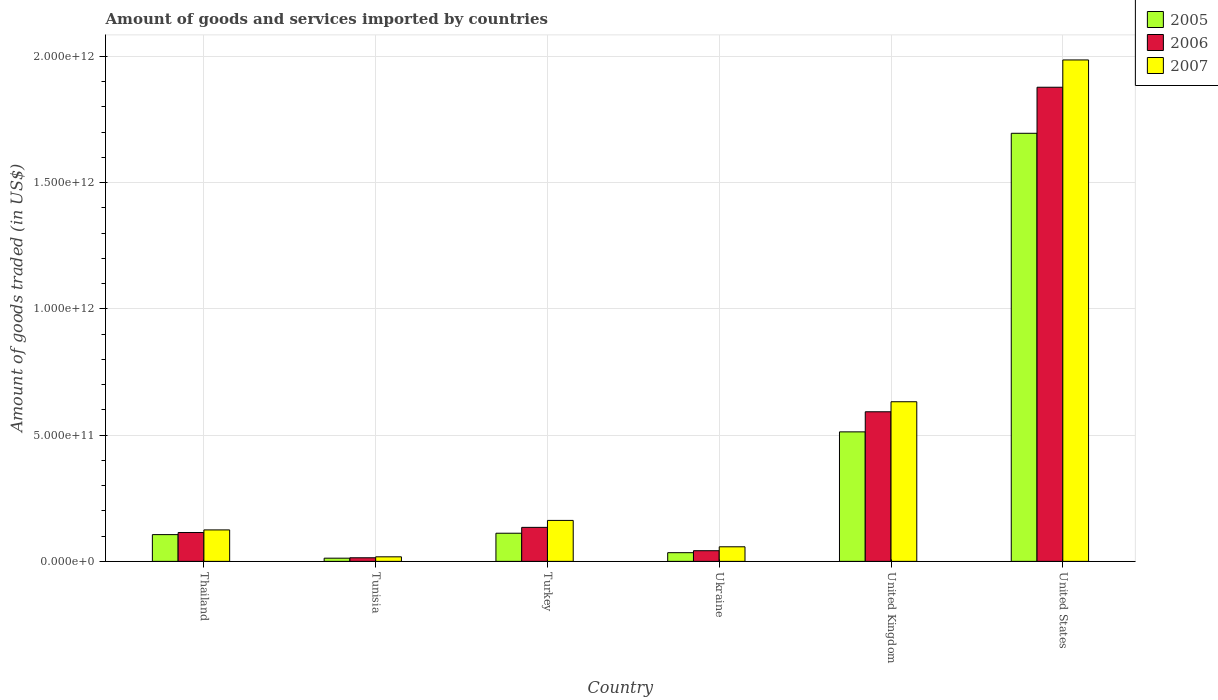How many different coloured bars are there?
Your response must be concise. 3. Are the number of bars per tick equal to the number of legend labels?
Your answer should be compact. Yes. Are the number of bars on each tick of the X-axis equal?
Ensure brevity in your answer.  Yes. What is the label of the 3rd group of bars from the left?
Your answer should be very brief. Turkey. In how many cases, is the number of bars for a given country not equal to the number of legend labels?
Offer a terse response. 0. What is the total amount of goods and services imported in 2007 in Thailand?
Ensure brevity in your answer.  1.25e+11. Across all countries, what is the maximum total amount of goods and services imported in 2007?
Keep it short and to the point. 1.99e+12. Across all countries, what is the minimum total amount of goods and services imported in 2006?
Your answer should be compact. 1.42e+1. In which country was the total amount of goods and services imported in 2007 maximum?
Make the answer very short. United States. In which country was the total amount of goods and services imported in 2005 minimum?
Provide a short and direct response. Tunisia. What is the total total amount of goods and services imported in 2005 in the graph?
Make the answer very short. 2.47e+12. What is the difference between the total amount of goods and services imported in 2005 in Thailand and that in Tunisia?
Your response must be concise. 9.34e+1. What is the difference between the total amount of goods and services imported in 2007 in Thailand and the total amount of goods and services imported in 2005 in Turkey?
Your response must be concise. 1.32e+1. What is the average total amount of goods and services imported in 2006 per country?
Ensure brevity in your answer.  4.63e+11. What is the difference between the total amount of goods and services imported of/in 2006 and total amount of goods and services imported of/in 2007 in United Kingdom?
Keep it short and to the point. -3.98e+1. What is the ratio of the total amount of goods and services imported in 2007 in Turkey to that in United Kingdom?
Give a very brief answer. 0.26. What is the difference between the highest and the second highest total amount of goods and services imported in 2005?
Offer a very short reply. 1.18e+12. What is the difference between the highest and the lowest total amount of goods and services imported in 2007?
Offer a terse response. 1.97e+12. Is the sum of the total amount of goods and services imported in 2007 in United Kingdom and United States greater than the maximum total amount of goods and services imported in 2006 across all countries?
Ensure brevity in your answer.  Yes. What does the 3rd bar from the left in United States represents?
Offer a very short reply. 2007. Is it the case that in every country, the sum of the total amount of goods and services imported in 2007 and total amount of goods and services imported in 2005 is greater than the total amount of goods and services imported in 2006?
Keep it short and to the point. Yes. Are all the bars in the graph horizontal?
Your answer should be very brief. No. What is the difference between two consecutive major ticks on the Y-axis?
Provide a short and direct response. 5.00e+11. Are the values on the major ticks of Y-axis written in scientific E-notation?
Your answer should be compact. Yes. Does the graph contain any zero values?
Keep it short and to the point. No. Does the graph contain grids?
Provide a succinct answer. Yes. Where does the legend appear in the graph?
Your response must be concise. Top right. How many legend labels are there?
Give a very brief answer. 3. What is the title of the graph?
Offer a terse response. Amount of goods and services imported by countries. What is the label or title of the X-axis?
Ensure brevity in your answer.  Country. What is the label or title of the Y-axis?
Give a very brief answer. Amount of goods traded (in US$). What is the Amount of goods traded (in US$) of 2005 in Thailand?
Provide a short and direct response. 1.06e+11. What is the Amount of goods traded (in US$) in 2006 in Thailand?
Make the answer very short. 1.14e+11. What is the Amount of goods traded (in US$) in 2007 in Thailand?
Provide a succinct answer. 1.25e+11. What is the Amount of goods traded (in US$) of 2005 in Tunisia?
Provide a succinct answer. 1.26e+1. What is the Amount of goods traded (in US$) in 2006 in Tunisia?
Make the answer very short. 1.42e+1. What is the Amount of goods traded (in US$) of 2007 in Tunisia?
Offer a very short reply. 1.80e+1. What is the Amount of goods traded (in US$) in 2005 in Turkey?
Offer a very short reply. 1.11e+11. What is the Amount of goods traded (in US$) of 2006 in Turkey?
Keep it short and to the point. 1.35e+11. What is the Amount of goods traded (in US$) in 2007 in Turkey?
Provide a succinct answer. 1.62e+11. What is the Amount of goods traded (in US$) of 2005 in Ukraine?
Ensure brevity in your answer.  3.44e+1. What is the Amount of goods traded (in US$) of 2006 in Ukraine?
Provide a succinct answer. 4.22e+1. What is the Amount of goods traded (in US$) of 2007 in Ukraine?
Provide a short and direct response. 5.78e+1. What is the Amount of goods traded (in US$) in 2005 in United Kingdom?
Provide a succinct answer. 5.13e+11. What is the Amount of goods traded (in US$) in 2006 in United Kingdom?
Make the answer very short. 5.93e+11. What is the Amount of goods traded (in US$) of 2007 in United Kingdom?
Ensure brevity in your answer.  6.32e+11. What is the Amount of goods traded (in US$) of 2005 in United States?
Keep it short and to the point. 1.70e+12. What is the Amount of goods traded (in US$) of 2006 in United States?
Offer a terse response. 1.88e+12. What is the Amount of goods traded (in US$) of 2007 in United States?
Your response must be concise. 1.99e+12. Across all countries, what is the maximum Amount of goods traded (in US$) in 2005?
Keep it short and to the point. 1.70e+12. Across all countries, what is the maximum Amount of goods traded (in US$) of 2006?
Offer a terse response. 1.88e+12. Across all countries, what is the maximum Amount of goods traded (in US$) of 2007?
Give a very brief answer. 1.99e+12. Across all countries, what is the minimum Amount of goods traded (in US$) in 2005?
Ensure brevity in your answer.  1.26e+1. Across all countries, what is the minimum Amount of goods traded (in US$) in 2006?
Offer a very short reply. 1.42e+1. Across all countries, what is the minimum Amount of goods traded (in US$) in 2007?
Your answer should be compact. 1.80e+1. What is the total Amount of goods traded (in US$) of 2005 in the graph?
Offer a very short reply. 2.47e+12. What is the total Amount of goods traded (in US$) in 2006 in the graph?
Keep it short and to the point. 2.78e+12. What is the total Amount of goods traded (in US$) in 2007 in the graph?
Your answer should be compact. 2.98e+12. What is the difference between the Amount of goods traded (in US$) in 2005 in Thailand and that in Tunisia?
Make the answer very short. 9.34e+1. What is the difference between the Amount of goods traded (in US$) in 2006 in Thailand and that in Tunisia?
Offer a very short reply. 1.00e+11. What is the difference between the Amount of goods traded (in US$) of 2007 in Thailand and that in Tunisia?
Offer a terse response. 1.07e+11. What is the difference between the Amount of goods traded (in US$) of 2005 in Thailand and that in Turkey?
Your response must be concise. -5.47e+09. What is the difference between the Amount of goods traded (in US$) of 2006 in Thailand and that in Turkey?
Provide a succinct answer. -2.04e+1. What is the difference between the Amount of goods traded (in US$) in 2007 in Thailand and that in Turkey?
Give a very brief answer. -3.76e+1. What is the difference between the Amount of goods traded (in US$) of 2005 in Thailand and that in Ukraine?
Make the answer very short. 7.16e+1. What is the difference between the Amount of goods traded (in US$) of 2006 in Thailand and that in Ukraine?
Ensure brevity in your answer.  7.20e+1. What is the difference between the Amount of goods traded (in US$) in 2007 in Thailand and that in Ukraine?
Keep it short and to the point. 6.69e+1. What is the difference between the Amount of goods traded (in US$) of 2005 in Thailand and that in United Kingdom?
Ensure brevity in your answer.  -4.07e+11. What is the difference between the Amount of goods traded (in US$) of 2006 in Thailand and that in United Kingdom?
Your answer should be very brief. -4.78e+11. What is the difference between the Amount of goods traded (in US$) of 2007 in Thailand and that in United Kingdom?
Ensure brevity in your answer.  -5.08e+11. What is the difference between the Amount of goods traded (in US$) of 2005 in Thailand and that in United States?
Provide a short and direct response. -1.59e+12. What is the difference between the Amount of goods traded (in US$) in 2006 in Thailand and that in United States?
Offer a terse response. -1.76e+12. What is the difference between the Amount of goods traded (in US$) in 2007 in Thailand and that in United States?
Ensure brevity in your answer.  -1.86e+12. What is the difference between the Amount of goods traded (in US$) of 2005 in Tunisia and that in Turkey?
Provide a succinct answer. -9.89e+1. What is the difference between the Amount of goods traded (in US$) in 2006 in Tunisia and that in Turkey?
Your answer should be compact. -1.20e+11. What is the difference between the Amount of goods traded (in US$) of 2007 in Tunisia and that in Turkey?
Provide a succinct answer. -1.44e+11. What is the difference between the Amount of goods traded (in US$) in 2005 in Tunisia and that in Ukraine?
Provide a succinct answer. -2.18e+1. What is the difference between the Amount of goods traded (in US$) of 2006 in Tunisia and that in Ukraine?
Provide a short and direct response. -2.80e+1. What is the difference between the Amount of goods traded (in US$) of 2007 in Tunisia and that in Ukraine?
Offer a very short reply. -3.97e+1. What is the difference between the Amount of goods traded (in US$) of 2005 in Tunisia and that in United Kingdom?
Your answer should be very brief. -5.00e+11. What is the difference between the Amount of goods traded (in US$) in 2006 in Tunisia and that in United Kingdom?
Provide a short and direct response. -5.78e+11. What is the difference between the Amount of goods traded (in US$) in 2007 in Tunisia and that in United Kingdom?
Offer a terse response. -6.14e+11. What is the difference between the Amount of goods traded (in US$) of 2005 in Tunisia and that in United States?
Your answer should be very brief. -1.68e+12. What is the difference between the Amount of goods traded (in US$) in 2006 in Tunisia and that in United States?
Give a very brief answer. -1.86e+12. What is the difference between the Amount of goods traded (in US$) of 2007 in Tunisia and that in United States?
Give a very brief answer. -1.97e+12. What is the difference between the Amount of goods traded (in US$) of 2005 in Turkey and that in Ukraine?
Provide a succinct answer. 7.71e+1. What is the difference between the Amount of goods traded (in US$) in 2006 in Turkey and that in Ukraine?
Provide a succinct answer. 9.25e+1. What is the difference between the Amount of goods traded (in US$) in 2007 in Turkey and that in Ukraine?
Keep it short and to the point. 1.04e+11. What is the difference between the Amount of goods traded (in US$) in 2005 in Turkey and that in United Kingdom?
Your answer should be compact. -4.02e+11. What is the difference between the Amount of goods traded (in US$) of 2006 in Turkey and that in United Kingdom?
Make the answer very short. -4.58e+11. What is the difference between the Amount of goods traded (in US$) in 2007 in Turkey and that in United Kingdom?
Your answer should be compact. -4.70e+11. What is the difference between the Amount of goods traded (in US$) in 2005 in Turkey and that in United States?
Your response must be concise. -1.58e+12. What is the difference between the Amount of goods traded (in US$) in 2006 in Turkey and that in United States?
Provide a short and direct response. -1.74e+12. What is the difference between the Amount of goods traded (in US$) of 2007 in Turkey and that in United States?
Make the answer very short. -1.82e+12. What is the difference between the Amount of goods traded (in US$) in 2005 in Ukraine and that in United Kingdom?
Keep it short and to the point. -4.79e+11. What is the difference between the Amount of goods traded (in US$) of 2006 in Ukraine and that in United Kingdom?
Provide a short and direct response. -5.50e+11. What is the difference between the Amount of goods traded (in US$) in 2007 in Ukraine and that in United Kingdom?
Make the answer very short. -5.75e+11. What is the difference between the Amount of goods traded (in US$) in 2005 in Ukraine and that in United States?
Your answer should be very brief. -1.66e+12. What is the difference between the Amount of goods traded (in US$) of 2006 in Ukraine and that in United States?
Offer a very short reply. -1.84e+12. What is the difference between the Amount of goods traded (in US$) of 2007 in Ukraine and that in United States?
Give a very brief answer. -1.93e+12. What is the difference between the Amount of goods traded (in US$) of 2005 in United Kingdom and that in United States?
Make the answer very short. -1.18e+12. What is the difference between the Amount of goods traded (in US$) in 2006 in United Kingdom and that in United States?
Give a very brief answer. -1.29e+12. What is the difference between the Amount of goods traded (in US$) in 2007 in United Kingdom and that in United States?
Ensure brevity in your answer.  -1.35e+12. What is the difference between the Amount of goods traded (in US$) in 2005 in Thailand and the Amount of goods traded (in US$) in 2006 in Tunisia?
Provide a short and direct response. 9.18e+1. What is the difference between the Amount of goods traded (in US$) in 2005 in Thailand and the Amount of goods traded (in US$) in 2007 in Tunisia?
Give a very brief answer. 8.80e+1. What is the difference between the Amount of goods traded (in US$) of 2006 in Thailand and the Amount of goods traded (in US$) of 2007 in Tunisia?
Your response must be concise. 9.62e+1. What is the difference between the Amount of goods traded (in US$) in 2005 in Thailand and the Amount of goods traded (in US$) in 2006 in Turkey?
Offer a very short reply. -2.87e+1. What is the difference between the Amount of goods traded (in US$) in 2005 in Thailand and the Amount of goods traded (in US$) in 2007 in Turkey?
Give a very brief answer. -5.62e+1. What is the difference between the Amount of goods traded (in US$) of 2006 in Thailand and the Amount of goods traded (in US$) of 2007 in Turkey?
Give a very brief answer. -4.79e+1. What is the difference between the Amount of goods traded (in US$) of 2005 in Thailand and the Amount of goods traded (in US$) of 2006 in Ukraine?
Your answer should be compact. 6.38e+1. What is the difference between the Amount of goods traded (in US$) in 2005 in Thailand and the Amount of goods traded (in US$) in 2007 in Ukraine?
Offer a terse response. 4.82e+1. What is the difference between the Amount of goods traded (in US$) of 2006 in Thailand and the Amount of goods traded (in US$) of 2007 in Ukraine?
Your answer should be compact. 5.65e+1. What is the difference between the Amount of goods traded (in US$) in 2005 in Thailand and the Amount of goods traded (in US$) in 2006 in United Kingdom?
Offer a very short reply. -4.87e+11. What is the difference between the Amount of goods traded (in US$) in 2005 in Thailand and the Amount of goods traded (in US$) in 2007 in United Kingdom?
Your response must be concise. -5.26e+11. What is the difference between the Amount of goods traded (in US$) in 2006 in Thailand and the Amount of goods traded (in US$) in 2007 in United Kingdom?
Your answer should be very brief. -5.18e+11. What is the difference between the Amount of goods traded (in US$) in 2005 in Thailand and the Amount of goods traded (in US$) in 2006 in United States?
Offer a very short reply. -1.77e+12. What is the difference between the Amount of goods traded (in US$) in 2005 in Thailand and the Amount of goods traded (in US$) in 2007 in United States?
Offer a very short reply. -1.88e+12. What is the difference between the Amount of goods traded (in US$) of 2006 in Thailand and the Amount of goods traded (in US$) of 2007 in United States?
Offer a very short reply. -1.87e+12. What is the difference between the Amount of goods traded (in US$) in 2005 in Tunisia and the Amount of goods traded (in US$) in 2006 in Turkey?
Give a very brief answer. -1.22e+11. What is the difference between the Amount of goods traded (in US$) in 2005 in Tunisia and the Amount of goods traded (in US$) in 2007 in Turkey?
Your answer should be compact. -1.50e+11. What is the difference between the Amount of goods traded (in US$) in 2006 in Tunisia and the Amount of goods traded (in US$) in 2007 in Turkey?
Make the answer very short. -1.48e+11. What is the difference between the Amount of goods traded (in US$) of 2005 in Tunisia and the Amount of goods traded (in US$) of 2006 in Ukraine?
Provide a succinct answer. -2.96e+1. What is the difference between the Amount of goods traded (in US$) of 2005 in Tunisia and the Amount of goods traded (in US$) of 2007 in Ukraine?
Offer a very short reply. -4.52e+1. What is the difference between the Amount of goods traded (in US$) of 2006 in Tunisia and the Amount of goods traded (in US$) of 2007 in Ukraine?
Ensure brevity in your answer.  -4.36e+1. What is the difference between the Amount of goods traded (in US$) of 2005 in Tunisia and the Amount of goods traded (in US$) of 2006 in United Kingdom?
Keep it short and to the point. -5.80e+11. What is the difference between the Amount of goods traded (in US$) in 2005 in Tunisia and the Amount of goods traded (in US$) in 2007 in United Kingdom?
Your answer should be very brief. -6.20e+11. What is the difference between the Amount of goods traded (in US$) of 2006 in Tunisia and the Amount of goods traded (in US$) of 2007 in United Kingdom?
Offer a terse response. -6.18e+11. What is the difference between the Amount of goods traded (in US$) of 2005 in Tunisia and the Amount of goods traded (in US$) of 2006 in United States?
Your answer should be compact. -1.87e+12. What is the difference between the Amount of goods traded (in US$) of 2005 in Tunisia and the Amount of goods traded (in US$) of 2007 in United States?
Make the answer very short. -1.97e+12. What is the difference between the Amount of goods traded (in US$) of 2006 in Tunisia and the Amount of goods traded (in US$) of 2007 in United States?
Make the answer very short. -1.97e+12. What is the difference between the Amount of goods traded (in US$) in 2005 in Turkey and the Amount of goods traded (in US$) in 2006 in Ukraine?
Offer a very short reply. 6.92e+1. What is the difference between the Amount of goods traded (in US$) of 2005 in Turkey and the Amount of goods traded (in US$) of 2007 in Ukraine?
Keep it short and to the point. 5.37e+1. What is the difference between the Amount of goods traded (in US$) of 2006 in Turkey and the Amount of goods traded (in US$) of 2007 in Ukraine?
Ensure brevity in your answer.  7.69e+1. What is the difference between the Amount of goods traded (in US$) of 2005 in Turkey and the Amount of goods traded (in US$) of 2006 in United Kingdom?
Your answer should be very brief. -4.81e+11. What is the difference between the Amount of goods traded (in US$) in 2005 in Turkey and the Amount of goods traded (in US$) in 2007 in United Kingdom?
Make the answer very short. -5.21e+11. What is the difference between the Amount of goods traded (in US$) in 2006 in Turkey and the Amount of goods traded (in US$) in 2007 in United Kingdom?
Offer a terse response. -4.98e+11. What is the difference between the Amount of goods traded (in US$) in 2005 in Turkey and the Amount of goods traded (in US$) in 2006 in United States?
Offer a terse response. -1.77e+12. What is the difference between the Amount of goods traded (in US$) in 2005 in Turkey and the Amount of goods traded (in US$) in 2007 in United States?
Your response must be concise. -1.87e+12. What is the difference between the Amount of goods traded (in US$) of 2006 in Turkey and the Amount of goods traded (in US$) of 2007 in United States?
Give a very brief answer. -1.85e+12. What is the difference between the Amount of goods traded (in US$) in 2005 in Ukraine and the Amount of goods traded (in US$) in 2006 in United Kingdom?
Give a very brief answer. -5.58e+11. What is the difference between the Amount of goods traded (in US$) of 2005 in Ukraine and the Amount of goods traded (in US$) of 2007 in United Kingdom?
Make the answer very short. -5.98e+11. What is the difference between the Amount of goods traded (in US$) in 2006 in Ukraine and the Amount of goods traded (in US$) in 2007 in United Kingdom?
Keep it short and to the point. -5.90e+11. What is the difference between the Amount of goods traded (in US$) in 2005 in Ukraine and the Amount of goods traded (in US$) in 2006 in United States?
Offer a very short reply. -1.84e+12. What is the difference between the Amount of goods traded (in US$) of 2005 in Ukraine and the Amount of goods traded (in US$) of 2007 in United States?
Ensure brevity in your answer.  -1.95e+12. What is the difference between the Amount of goods traded (in US$) of 2006 in Ukraine and the Amount of goods traded (in US$) of 2007 in United States?
Your answer should be compact. -1.94e+12. What is the difference between the Amount of goods traded (in US$) of 2005 in United Kingdom and the Amount of goods traded (in US$) of 2006 in United States?
Give a very brief answer. -1.37e+12. What is the difference between the Amount of goods traded (in US$) in 2005 in United Kingdom and the Amount of goods traded (in US$) in 2007 in United States?
Keep it short and to the point. -1.47e+12. What is the difference between the Amount of goods traded (in US$) of 2006 in United Kingdom and the Amount of goods traded (in US$) of 2007 in United States?
Make the answer very short. -1.39e+12. What is the average Amount of goods traded (in US$) in 2005 per country?
Provide a succinct answer. 4.12e+11. What is the average Amount of goods traded (in US$) in 2006 per country?
Offer a very short reply. 4.63e+11. What is the average Amount of goods traded (in US$) of 2007 per country?
Keep it short and to the point. 4.97e+11. What is the difference between the Amount of goods traded (in US$) in 2005 and Amount of goods traded (in US$) in 2006 in Thailand?
Offer a terse response. -8.29e+09. What is the difference between the Amount of goods traded (in US$) of 2005 and Amount of goods traded (in US$) of 2007 in Thailand?
Your answer should be compact. -1.86e+1. What is the difference between the Amount of goods traded (in US$) of 2006 and Amount of goods traded (in US$) of 2007 in Thailand?
Your answer should be very brief. -1.03e+1. What is the difference between the Amount of goods traded (in US$) in 2005 and Amount of goods traded (in US$) in 2006 in Tunisia?
Give a very brief answer. -1.61e+09. What is the difference between the Amount of goods traded (in US$) of 2005 and Amount of goods traded (in US$) of 2007 in Tunisia?
Your answer should be very brief. -5.43e+09. What is the difference between the Amount of goods traded (in US$) in 2006 and Amount of goods traded (in US$) in 2007 in Tunisia?
Give a very brief answer. -3.82e+09. What is the difference between the Amount of goods traded (in US$) of 2005 and Amount of goods traded (in US$) of 2006 in Turkey?
Your answer should be very brief. -2.32e+1. What is the difference between the Amount of goods traded (in US$) in 2005 and Amount of goods traded (in US$) in 2007 in Turkey?
Provide a short and direct response. -5.08e+1. What is the difference between the Amount of goods traded (in US$) in 2006 and Amount of goods traded (in US$) in 2007 in Turkey?
Ensure brevity in your answer.  -2.75e+1. What is the difference between the Amount of goods traded (in US$) in 2005 and Amount of goods traded (in US$) in 2006 in Ukraine?
Offer a terse response. -7.84e+09. What is the difference between the Amount of goods traded (in US$) in 2005 and Amount of goods traded (in US$) in 2007 in Ukraine?
Your answer should be compact. -2.34e+1. What is the difference between the Amount of goods traded (in US$) in 2006 and Amount of goods traded (in US$) in 2007 in Ukraine?
Provide a succinct answer. -1.55e+1. What is the difference between the Amount of goods traded (in US$) in 2005 and Amount of goods traded (in US$) in 2006 in United Kingdom?
Keep it short and to the point. -7.96e+1. What is the difference between the Amount of goods traded (in US$) in 2005 and Amount of goods traded (in US$) in 2007 in United Kingdom?
Keep it short and to the point. -1.19e+11. What is the difference between the Amount of goods traded (in US$) in 2006 and Amount of goods traded (in US$) in 2007 in United Kingdom?
Provide a succinct answer. -3.98e+1. What is the difference between the Amount of goods traded (in US$) of 2005 and Amount of goods traded (in US$) of 2006 in United States?
Keep it short and to the point. -1.82e+11. What is the difference between the Amount of goods traded (in US$) of 2005 and Amount of goods traded (in US$) of 2007 in United States?
Provide a succinct answer. -2.91e+11. What is the difference between the Amount of goods traded (in US$) of 2006 and Amount of goods traded (in US$) of 2007 in United States?
Your response must be concise. -1.08e+11. What is the ratio of the Amount of goods traded (in US$) of 2005 in Thailand to that in Tunisia?
Make the answer very short. 8.41. What is the ratio of the Amount of goods traded (in US$) in 2006 in Thailand to that in Tunisia?
Give a very brief answer. 8.05. What is the ratio of the Amount of goods traded (in US$) of 2007 in Thailand to that in Tunisia?
Ensure brevity in your answer.  6.91. What is the ratio of the Amount of goods traded (in US$) of 2005 in Thailand to that in Turkey?
Ensure brevity in your answer.  0.95. What is the ratio of the Amount of goods traded (in US$) in 2006 in Thailand to that in Turkey?
Your answer should be compact. 0.85. What is the ratio of the Amount of goods traded (in US$) in 2007 in Thailand to that in Turkey?
Your answer should be very brief. 0.77. What is the ratio of the Amount of goods traded (in US$) in 2005 in Thailand to that in Ukraine?
Provide a succinct answer. 3.08. What is the ratio of the Amount of goods traded (in US$) in 2006 in Thailand to that in Ukraine?
Make the answer very short. 2.71. What is the ratio of the Amount of goods traded (in US$) in 2007 in Thailand to that in Ukraine?
Ensure brevity in your answer.  2.16. What is the ratio of the Amount of goods traded (in US$) of 2005 in Thailand to that in United Kingdom?
Provide a succinct answer. 0.21. What is the ratio of the Amount of goods traded (in US$) of 2006 in Thailand to that in United Kingdom?
Offer a very short reply. 0.19. What is the ratio of the Amount of goods traded (in US$) in 2007 in Thailand to that in United Kingdom?
Ensure brevity in your answer.  0.2. What is the ratio of the Amount of goods traded (in US$) in 2005 in Thailand to that in United States?
Make the answer very short. 0.06. What is the ratio of the Amount of goods traded (in US$) of 2006 in Thailand to that in United States?
Your response must be concise. 0.06. What is the ratio of the Amount of goods traded (in US$) in 2007 in Thailand to that in United States?
Your answer should be compact. 0.06. What is the ratio of the Amount of goods traded (in US$) of 2005 in Tunisia to that in Turkey?
Ensure brevity in your answer.  0.11. What is the ratio of the Amount of goods traded (in US$) in 2006 in Tunisia to that in Turkey?
Your answer should be very brief. 0.11. What is the ratio of the Amount of goods traded (in US$) in 2005 in Tunisia to that in Ukraine?
Make the answer very short. 0.37. What is the ratio of the Amount of goods traded (in US$) of 2006 in Tunisia to that in Ukraine?
Your answer should be very brief. 0.34. What is the ratio of the Amount of goods traded (in US$) of 2007 in Tunisia to that in Ukraine?
Keep it short and to the point. 0.31. What is the ratio of the Amount of goods traded (in US$) in 2005 in Tunisia to that in United Kingdom?
Give a very brief answer. 0.02. What is the ratio of the Amount of goods traded (in US$) in 2006 in Tunisia to that in United Kingdom?
Your response must be concise. 0.02. What is the ratio of the Amount of goods traded (in US$) of 2007 in Tunisia to that in United Kingdom?
Make the answer very short. 0.03. What is the ratio of the Amount of goods traded (in US$) of 2005 in Tunisia to that in United States?
Your answer should be very brief. 0.01. What is the ratio of the Amount of goods traded (in US$) in 2006 in Tunisia to that in United States?
Give a very brief answer. 0.01. What is the ratio of the Amount of goods traded (in US$) of 2007 in Tunisia to that in United States?
Make the answer very short. 0.01. What is the ratio of the Amount of goods traded (in US$) in 2005 in Turkey to that in Ukraine?
Your response must be concise. 3.24. What is the ratio of the Amount of goods traded (in US$) in 2006 in Turkey to that in Ukraine?
Make the answer very short. 3.19. What is the ratio of the Amount of goods traded (in US$) of 2007 in Turkey to that in Ukraine?
Your response must be concise. 2.81. What is the ratio of the Amount of goods traded (in US$) of 2005 in Turkey to that in United Kingdom?
Provide a short and direct response. 0.22. What is the ratio of the Amount of goods traded (in US$) of 2006 in Turkey to that in United Kingdom?
Provide a succinct answer. 0.23. What is the ratio of the Amount of goods traded (in US$) of 2007 in Turkey to that in United Kingdom?
Offer a very short reply. 0.26. What is the ratio of the Amount of goods traded (in US$) of 2005 in Turkey to that in United States?
Provide a short and direct response. 0.07. What is the ratio of the Amount of goods traded (in US$) in 2006 in Turkey to that in United States?
Provide a short and direct response. 0.07. What is the ratio of the Amount of goods traded (in US$) of 2007 in Turkey to that in United States?
Provide a succinct answer. 0.08. What is the ratio of the Amount of goods traded (in US$) of 2005 in Ukraine to that in United Kingdom?
Provide a succinct answer. 0.07. What is the ratio of the Amount of goods traded (in US$) of 2006 in Ukraine to that in United Kingdom?
Offer a very short reply. 0.07. What is the ratio of the Amount of goods traded (in US$) of 2007 in Ukraine to that in United Kingdom?
Ensure brevity in your answer.  0.09. What is the ratio of the Amount of goods traded (in US$) in 2005 in Ukraine to that in United States?
Your answer should be compact. 0.02. What is the ratio of the Amount of goods traded (in US$) of 2006 in Ukraine to that in United States?
Your response must be concise. 0.02. What is the ratio of the Amount of goods traded (in US$) of 2007 in Ukraine to that in United States?
Give a very brief answer. 0.03. What is the ratio of the Amount of goods traded (in US$) in 2005 in United Kingdom to that in United States?
Keep it short and to the point. 0.3. What is the ratio of the Amount of goods traded (in US$) in 2006 in United Kingdom to that in United States?
Ensure brevity in your answer.  0.32. What is the ratio of the Amount of goods traded (in US$) of 2007 in United Kingdom to that in United States?
Your answer should be compact. 0.32. What is the difference between the highest and the second highest Amount of goods traded (in US$) in 2005?
Your answer should be compact. 1.18e+12. What is the difference between the highest and the second highest Amount of goods traded (in US$) of 2006?
Make the answer very short. 1.29e+12. What is the difference between the highest and the second highest Amount of goods traded (in US$) in 2007?
Provide a succinct answer. 1.35e+12. What is the difference between the highest and the lowest Amount of goods traded (in US$) in 2005?
Offer a very short reply. 1.68e+12. What is the difference between the highest and the lowest Amount of goods traded (in US$) in 2006?
Your response must be concise. 1.86e+12. What is the difference between the highest and the lowest Amount of goods traded (in US$) of 2007?
Provide a succinct answer. 1.97e+12. 